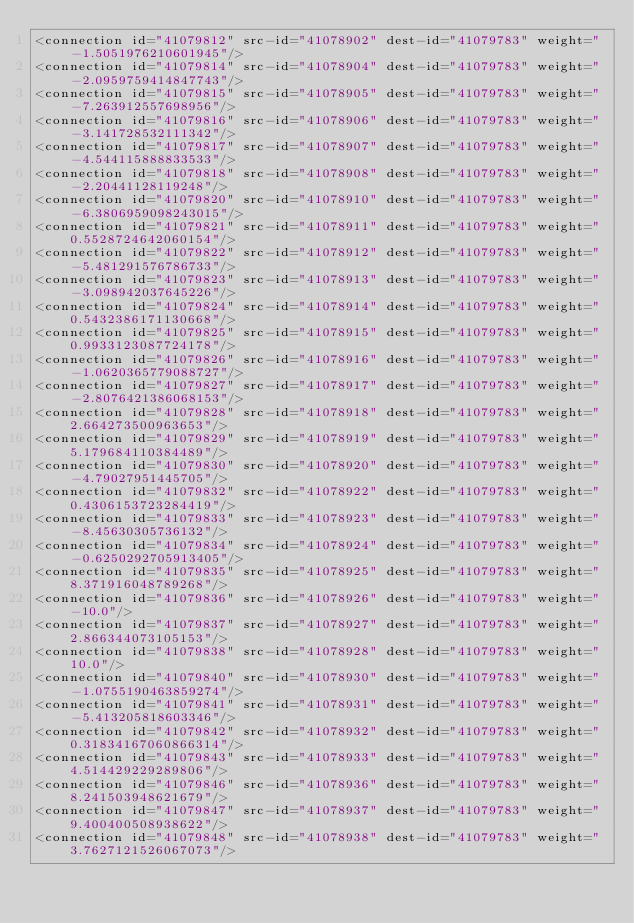Convert code to text. <code><loc_0><loc_0><loc_500><loc_500><_XML_><connection id="41079812" src-id="41078902" dest-id="41079783" weight="-1.5051976210601945"/>
<connection id="41079814" src-id="41078904" dest-id="41079783" weight="-2.0959759414847743"/>
<connection id="41079815" src-id="41078905" dest-id="41079783" weight="-7.263912557698956"/>
<connection id="41079816" src-id="41078906" dest-id="41079783" weight="-3.141728532111342"/>
<connection id="41079817" src-id="41078907" dest-id="41079783" weight="-4.544115888833533"/>
<connection id="41079818" src-id="41078908" dest-id="41079783" weight="-2.20441128119248"/>
<connection id="41079820" src-id="41078910" dest-id="41079783" weight="-6.3806959098243015"/>
<connection id="41079821" src-id="41078911" dest-id="41079783" weight="0.5528724642060154"/>
<connection id="41079822" src-id="41078912" dest-id="41079783" weight="-5.481291576786733"/>
<connection id="41079823" src-id="41078913" dest-id="41079783" weight="-3.098942037645226"/>
<connection id="41079824" src-id="41078914" dest-id="41079783" weight="0.5432386171130668"/>
<connection id="41079825" src-id="41078915" dest-id="41079783" weight="0.9933123087724178"/>
<connection id="41079826" src-id="41078916" dest-id="41079783" weight="-1.0620365779088727"/>
<connection id="41079827" src-id="41078917" dest-id="41079783" weight="-2.8076421386068153"/>
<connection id="41079828" src-id="41078918" dest-id="41079783" weight="2.664273500963653"/>
<connection id="41079829" src-id="41078919" dest-id="41079783" weight="5.179684110384489"/>
<connection id="41079830" src-id="41078920" dest-id="41079783" weight="-4.79027951445705"/>
<connection id="41079832" src-id="41078922" dest-id="41079783" weight="0.4306153723284419"/>
<connection id="41079833" src-id="41078923" dest-id="41079783" weight="-8.45630305736132"/>
<connection id="41079834" src-id="41078924" dest-id="41079783" weight="-0.6250292705913405"/>
<connection id="41079835" src-id="41078925" dest-id="41079783" weight="8.371916048789268"/>
<connection id="41079836" src-id="41078926" dest-id="41079783" weight="-10.0"/>
<connection id="41079837" src-id="41078927" dest-id="41079783" weight="2.866344073105153"/>
<connection id="41079838" src-id="41078928" dest-id="41079783" weight="10.0"/>
<connection id="41079840" src-id="41078930" dest-id="41079783" weight="-1.0755190463859274"/>
<connection id="41079841" src-id="41078931" dest-id="41079783" weight="-5.413205818603346"/>
<connection id="41079842" src-id="41078932" dest-id="41079783" weight="0.31834167060866314"/>
<connection id="41079843" src-id="41078933" dest-id="41079783" weight="4.514429229289806"/>
<connection id="41079846" src-id="41078936" dest-id="41079783" weight="8.241503948621679"/>
<connection id="41079847" src-id="41078937" dest-id="41079783" weight="9.400400508938622"/>
<connection id="41079848" src-id="41078938" dest-id="41079783" weight="3.7627121526067073"/></code> 